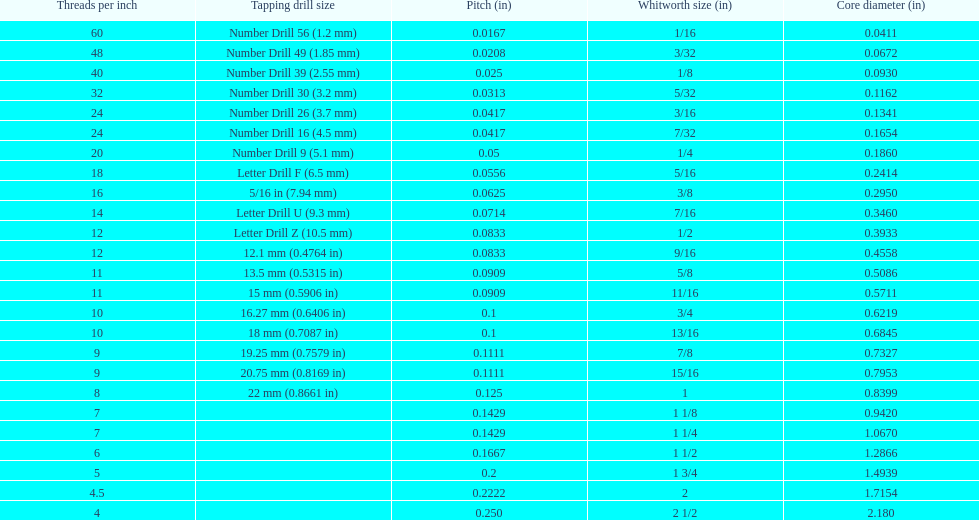Does any whitworth size have the same core diameter as the number drill 26? 3/16. 